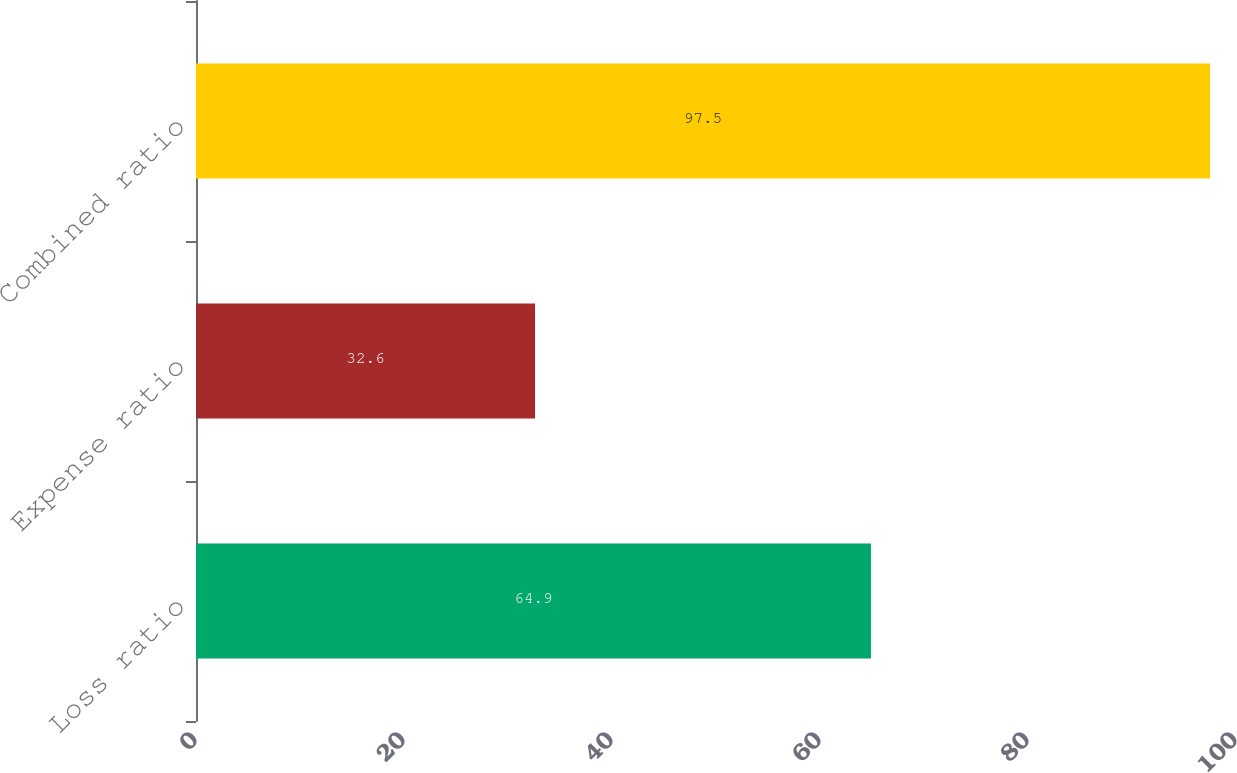Convert chart. <chart><loc_0><loc_0><loc_500><loc_500><bar_chart><fcel>Loss ratio<fcel>Expense ratio<fcel>Combined ratio<nl><fcel>64.9<fcel>32.6<fcel>97.5<nl></chart> 